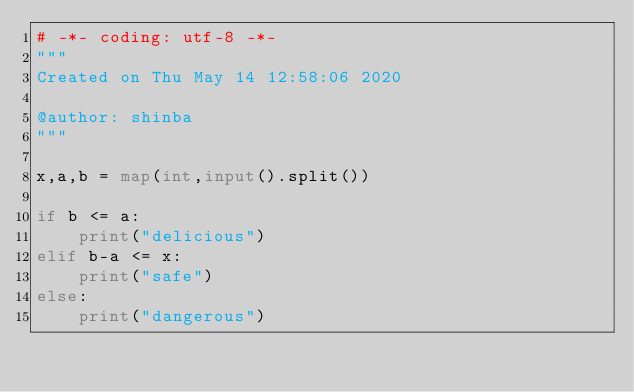Convert code to text. <code><loc_0><loc_0><loc_500><loc_500><_Python_># -*- coding: utf-8 -*-
"""
Created on Thu May 14 12:58:06 2020

@author: shinba
"""

x,a,b = map(int,input().split())

if b <= a:
    print("delicious")
elif b-a <= x:
    print("safe")
else:
    print("dangerous")</code> 